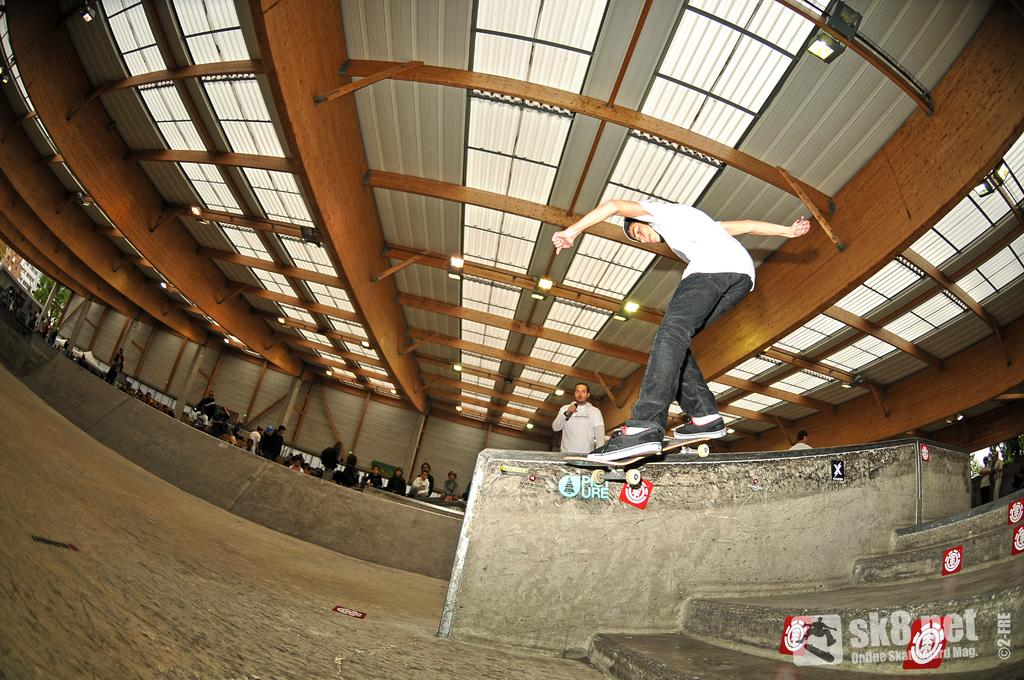What is the main activity being performed by the person in the image? There is a person skating on a ramp in the image. Can you describe the surroundings of the person skating? There are people in the background of the image, and there are lights visible at the top of the image. What architectural feature is present on the right side of the image? There are stairs on the right side of the image. What type of necklace is the person wearing while skating in the image? There is no necklace visible in the image; the person is wearing skating gear. Can you describe the contents of the basket in the image? There is no basket present in the image. 